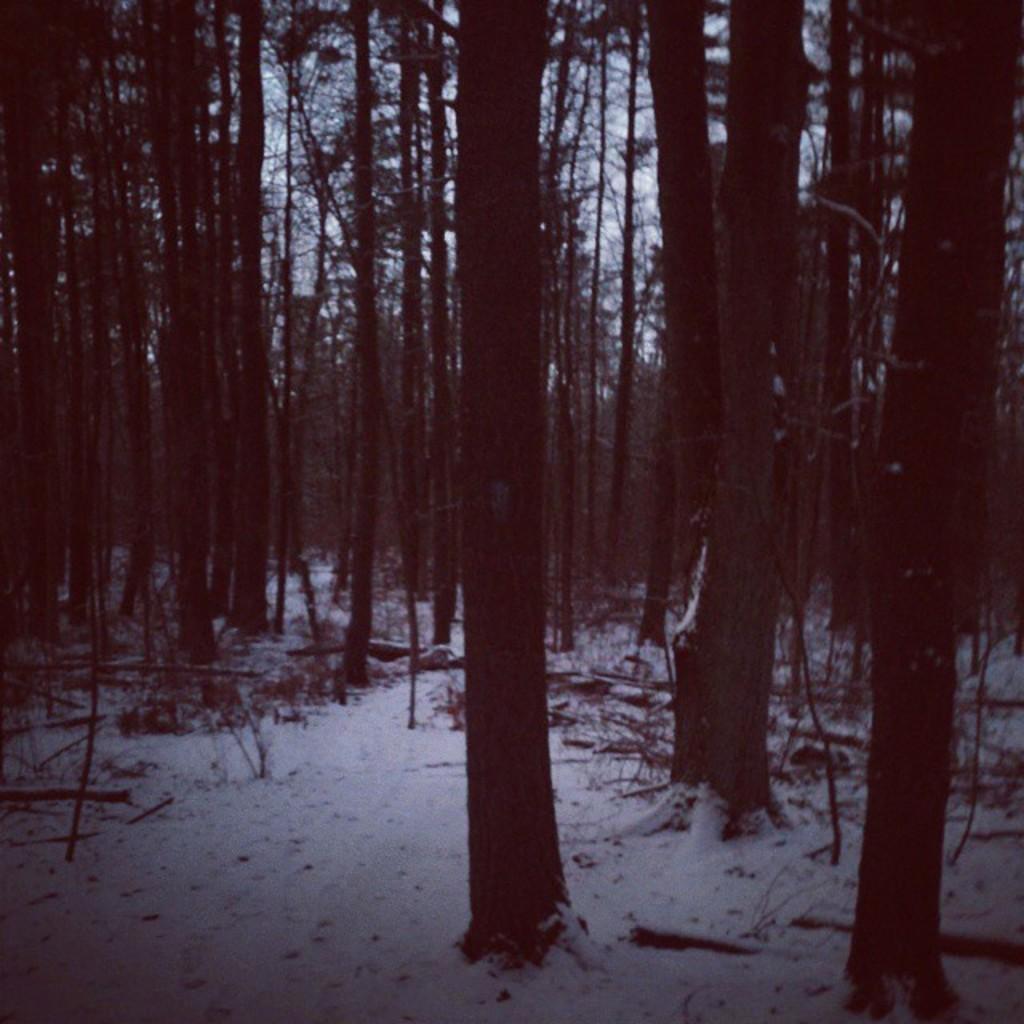Describe this image in one or two sentences. Here in this picture we can see the ground is fully covered with snow and we can also see plants and trees covered all over there and we can see the sky is cloudy. 